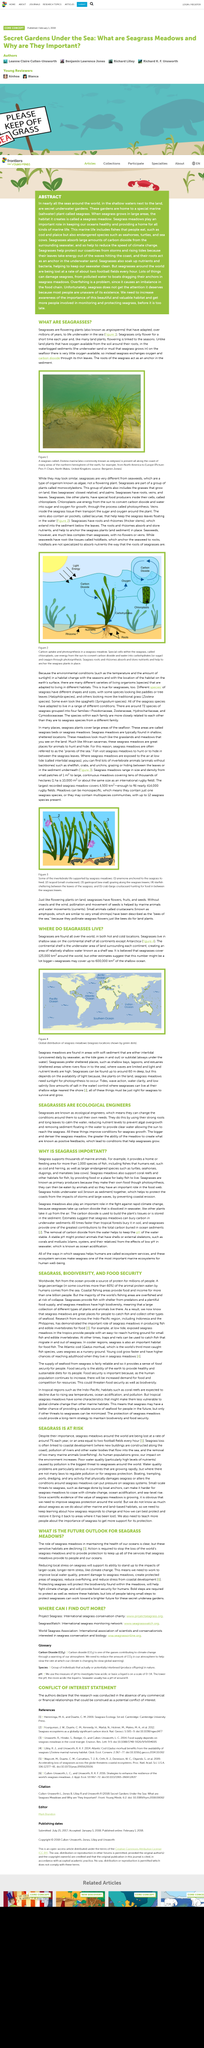Specify some key components in this picture. Seagrass meadows support a diverse range of invertebrate species, including shellfish, crabs, urchins, anemones, isopods, gastropods, and starfish. Seagrass is present all along the coast of the northern hemisphere of the earth. Seagrasses are a group of plants that belong to the monocotyledons. The air pockets within seagrass leaves that help keep them afloat are called lacu nae. The roots of seagrass serve as anchors in sediment, providing stability and preventing the seagrass from being swept away by currents. 